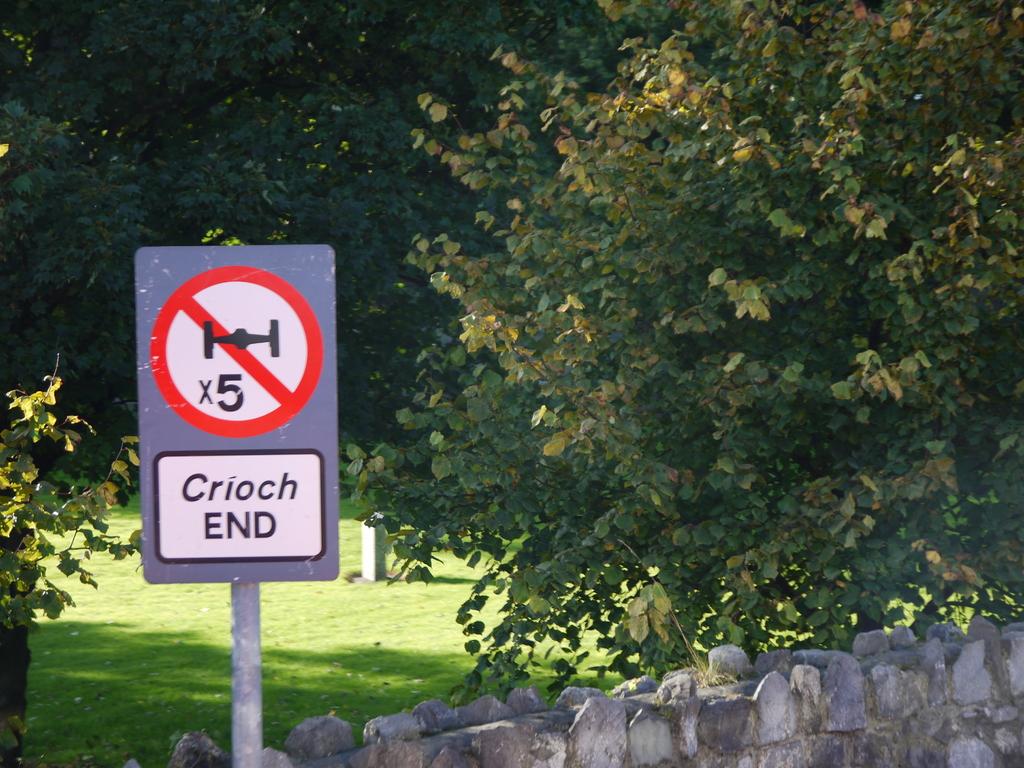What's the number on the sign?
Your response must be concise. 5. 